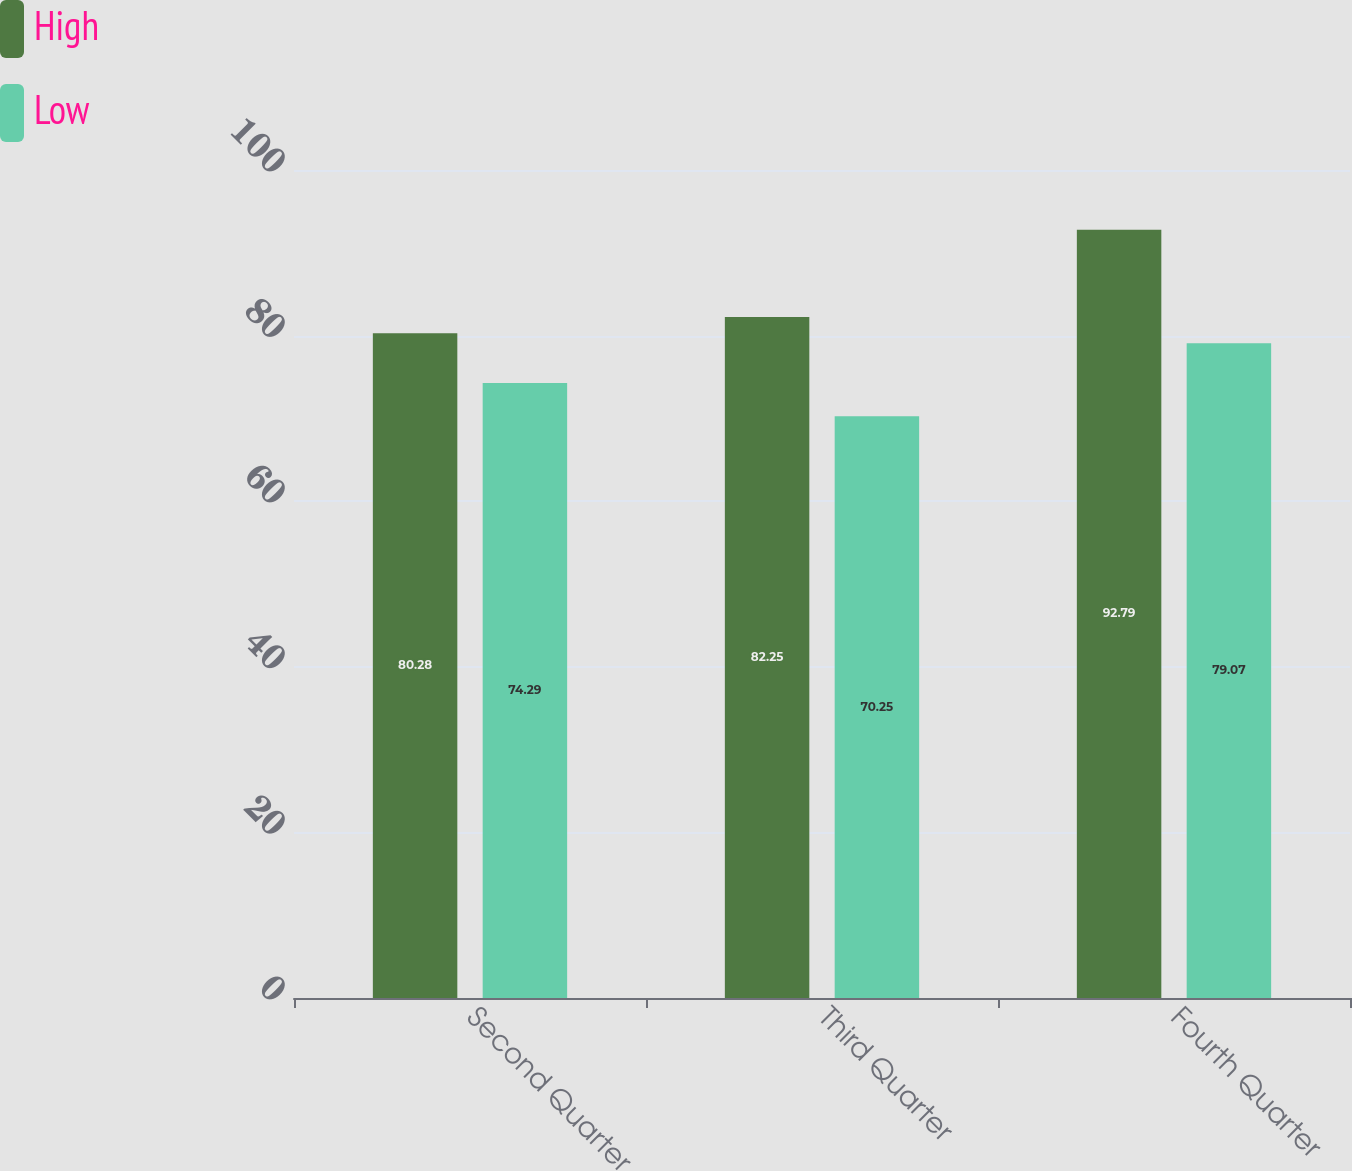<chart> <loc_0><loc_0><loc_500><loc_500><stacked_bar_chart><ecel><fcel>Second Quarter<fcel>Third Quarter<fcel>Fourth Quarter<nl><fcel>High<fcel>80.28<fcel>82.25<fcel>92.79<nl><fcel>Low<fcel>74.29<fcel>70.25<fcel>79.07<nl></chart> 